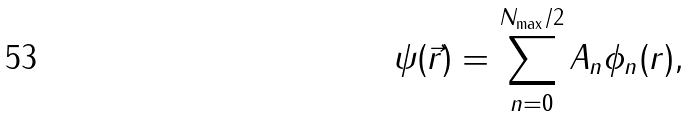Convert formula to latex. <formula><loc_0><loc_0><loc_500><loc_500>\psi ( \vec { r } ) = \sum _ { n = 0 } ^ { N _ { \max } / 2 } A _ { n } \phi _ { n } ( r ) ,</formula> 